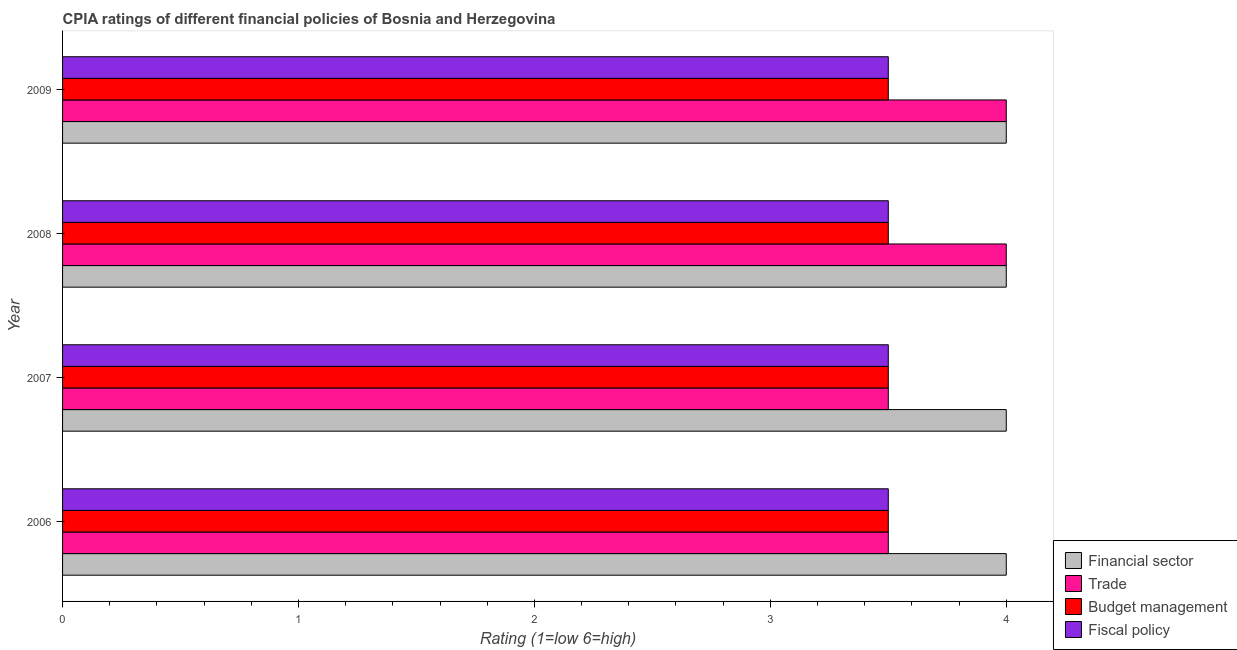How many groups of bars are there?
Your answer should be very brief. 4. How many bars are there on the 3rd tick from the bottom?
Provide a succinct answer. 4. What is the label of the 3rd group of bars from the top?
Your answer should be compact. 2007. What is the cpia rating of fiscal policy in 2007?
Ensure brevity in your answer.  3.5. Across all years, what is the maximum cpia rating of budget management?
Give a very brief answer. 3.5. Across all years, what is the minimum cpia rating of trade?
Provide a succinct answer. 3.5. In which year was the cpia rating of trade minimum?
Offer a very short reply. 2006. What is the difference between the cpia rating of financial sector in 2006 and that in 2009?
Your response must be concise. 0. What is the average cpia rating of financial sector per year?
Offer a very short reply. 4. What is the ratio of the cpia rating of financial sector in 2006 to that in 2008?
Give a very brief answer. 1. Is the cpia rating of budget management in 2006 less than that in 2007?
Offer a very short reply. No. What is the difference between the highest and the second highest cpia rating of trade?
Offer a terse response. 0. In how many years, is the cpia rating of trade greater than the average cpia rating of trade taken over all years?
Your response must be concise. 2. Is it the case that in every year, the sum of the cpia rating of budget management and cpia rating of trade is greater than the sum of cpia rating of fiscal policy and cpia rating of financial sector?
Your response must be concise. No. What does the 3rd bar from the top in 2007 represents?
Make the answer very short. Trade. What does the 1st bar from the bottom in 2007 represents?
Ensure brevity in your answer.  Financial sector. Are all the bars in the graph horizontal?
Make the answer very short. Yes. What is the difference between two consecutive major ticks on the X-axis?
Provide a short and direct response. 1. Does the graph contain any zero values?
Your answer should be very brief. No. Where does the legend appear in the graph?
Keep it short and to the point. Bottom right. How many legend labels are there?
Keep it short and to the point. 4. What is the title of the graph?
Your answer should be compact. CPIA ratings of different financial policies of Bosnia and Herzegovina. Does "WHO" appear as one of the legend labels in the graph?
Your answer should be compact. No. What is the label or title of the Y-axis?
Keep it short and to the point. Year. What is the Rating (1=low 6=high) of Financial sector in 2006?
Offer a terse response. 4. What is the Rating (1=low 6=high) in Trade in 2006?
Offer a very short reply. 3.5. What is the Rating (1=low 6=high) of Budget management in 2006?
Your answer should be very brief. 3.5. What is the Rating (1=low 6=high) in Fiscal policy in 2006?
Give a very brief answer. 3.5. What is the Rating (1=low 6=high) of Financial sector in 2007?
Make the answer very short. 4. What is the Rating (1=low 6=high) of Budget management in 2007?
Make the answer very short. 3.5. What is the Rating (1=low 6=high) in Fiscal policy in 2007?
Your answer should be compact. 3.5. What is the Rating (1=low 6=high) in Financial sector in 2008?
Provide a succinct answer. 4. What is the Rating (1=low 6=high) of Budget management in 2008?
Make the answer very short. 3.5. What is the Rating (1=low 6=high) of Fiscal policy in 2008?
Ensure brevity in your answer.  3.5. What is the Rating (1=low 6=high) of Financial sector in 2009?
Your response must be concise. 4. What is the Rating (1=low 6=high) in Budget management in 2009?
Make the answer very short. 3.5. Across all years, what is the maximum Rating (1=low 6=high) of Budget management?
Provide a succinct answer. 3.5. Across all years, what is the minimum Rating (1=low 6=high) in Trade?
Make the answer very short. 3.5. Across all years, what is the minimum Rating (1=low 6=high) of Budget management?
Your answer should be compact. 3.5. What is the total Rating (1=low 6=high) of Trade in the graph?
Provide a short and direct response. 15. What is the total Rating (1=low 6=high) in Budget management in the graph?
Your answer should be compact. 14. What is the total Rating (1=low 6=high) in Fiscal policy in the graph?
Offer a terse response. 14. What is the difference between the Rating (1=low 6=high) in Financial sector in 2006 and that in 2007?
Your response must be concise. 0. What is the difference between the Rating (1=low 6=high) in Trade in 2006 and that in 2007?
Your answer should be very brief. 0. What is the difference between the Rating (1=low 6=high) in Budget management in 2006 and that in 2007?
Provide a short and direct response. 0. What is the difference between the Rating (1=low 6=high) in Fiscal policy in 2006 and that in 2007?
Provide a succinct answer. 0. What is the difference between the Rating (1=low 6=high) in Financial sector in 2006 and that in 2008?
Provide a short and direct response. 0. What is the difference between the Rating (1=low 6=high) of Budget management in 2006 and that in 2008?
Provide a short and direct response. 0. What is the difference between the Rating (1=low 6=high) of Fiscal policy in 2006 and that in 2008?
Offer a very short reply. 0. What is the difference between the Rating (1=low 6=high) in Budget management in 2006 and that in 2009?
Give a very brief answer. 0. What is the difference between the Rating (1=low 6=high) in Trade in 2007 and that in 2008?
Offer a very short reply. -0.5. What is the difference between the Rating (1=low 6=high) in Fiscal policy in 2007 and that in 2008?
Provide a succinct answer. 0. What is the difference between the Rating (1=low 6=high) of Financial sector in 2007 and that in 2009?
Provide a succinct answer. 0. What is the difference between the Rating (1=low 6=high) of Trade in 2007 and that in 2009?
Ensure brevity in your answer.  -0.5. What is the difference between the Rating (1=low 6=high) in Budget management in 2007 and that in 2009?
Your answer should be very brief. 0. What is the difference between the Rating (1=low 6=high) in Financial sector in 2008 and that in 2009?
Make the answer very short. 0. What is the difference between the Rating (1=low 6=high) of Budget management in 2008 and that in 2009?
Provide a short and direct response. 0. What is the difference between the Rating (1=low 6=high) of Financial sector in 2006 and the Rating (1=low 6=high) of Trade in 2007?
Offer a terse response. 0.5. What is the difference between the Rating (1=low 6=high) in Financial sector in 2006 and the Rating (1=low 6=high) in Budget management in 2007?
Provide a succinct answer. 0.5. What is the difference between the Rating (1=low 6=high) of Financial sector in 2006 and the Rating (1=low 6=high) of Fiscal policy in 2007?
Offer a terse response. 0.5. What is the difference between the Rating (1=low 6=high) of Financial sector in 2006 and the Rating (1=low 6=high) of Budget management in 2008?
Make the answer very short. 0.5. What is the difference between the Rating (1=low 6=high) of Financial sector in 2006 and the Rating (1=low 6=high) of Fiscal policy in 2008?
Your answer should be compact. 0.5. What is the difference between the Rating (1=low 6=high) in Trade in 2006 and the Rating (1=low 6=high) in Budget management in 2008?
Keep it short and to the point. 0. What is the difference between the Rating (1=low 6=high) in Trade in 2006 and the Rating (1=low 6=high) in Fiscal policy in 2008?
Make the answer very short. 0. What is the difference between the Rating (1=low 6=high) in Budget management in 2006 and the Rating (1=low 6=high) in Fiscal policy in 2008?
Your response must be concise. 0. What is the difference between the Rating (1=low 6=high) of Financial sector in 2006 and the Rating (1=low 6=high) of Trade in 2009?
Your answer should be compact. 0. What is the difference between the Rating (1=low 6=high) of Financial sector in 2006 and the Rating (1=low 6=high) of Budget management in 2009?
Ensure brevity in your answer.  0.5. What is the difference between the Rating (1=low 6=high) of Financial sector in 2006 and the Rating (1=low 6=high) of Fiscal policy in 2009?
Keep it short and to the point. 0.5. What is the difference between the Rating (1=low 6=high) of Trade in 2006 and the Rating (1=low 6=high) of Budget management in 2009?
Your answer should be compact. 0. What is the difference between the Rating (1=low 6=high) in Budget management in 2006 and the Rating (1=low 6=high) in Fiscal policy in 2009?
Make the answer very short. 0. What is the difference between the Rating (1=low 6=high) of Trade in 2007 and the Rating (1=low 6=high) of Budget management in 2008?
Offer a very short reply. 0. What is the difference between the Rating (1=low 6=high) in Financial sector in 2007 and the Rating (1=low 6=high) in Budget management in 2009?
Your answer should be very brief. 0.5. What is the difference between the Rating (1=low 6=high) of Trade in 2007 and the Rating (1=low 6=high) of Budget management in 2009?
Give a very brief answer. 0. What is the difference between the Rating (1=low 6=high) of Trade in 2007 and the Rating (1=low 6=high) of Fiscal policy in 2009?
Ensure brevity in your answer.  0. What is the difference between the Rating (1=low 6=high) of Budget management in 2007 and the Rating (1=low 6=high) of Fiscal policy in 2009?
Offer a terse response. 0. What is the difference between the Rating (1=low 6=high) of Financial sector in 2008 and the Rating (1=low 6=high) of Budget management in 2009?
Ensure brevity in your answer.  0.5. What is the difference between the Rating (1=low 6=high) in Trade in 2008 and the Rating (1=low 6=high) in Budget management in 2009?
Provide a short and direct response. 0.5. What is the difference between the Rating (1=low 6=high) in Budget management in 2008 and the Rating (1=low 6=high) in Fiscal policy in 2009?
Your response must be concise. 0. What is the average Rating (1=low 6=high) of Trade per year?
Give a very brief answer. 3.75. What is the average Rating (1=low 6=high) of Budget management per year?
Provide a short and direct response. 3.5. In the year 2006, what is the difference between the Rating (1=low 6=high) of Trade and Rating (1=low 6=high) of Budget management?
Offer a terse response. 0. In the year 2006, what is the difference between the Rating (1=low 6=high) in Trade and Rating (1=low 6=high) in Fiscal policy?
Ensure brevity in your answer.  0. In the year 2007, what is the difference between the Rating (1=low 6=high) of Financial sector and Rating (1=low 6=high) of Trade?
Your answer should be compact. 0.5. In the year 2007, what is the difference between the Rating (1=low 6=high) in Financial sector and Rating (1=low 6=high) in Budget management?
Your answer should be very brief. 0.5. In the year 2007, what is the difference between the Rating (1=low 6=high) in Financial sector and Rating (1=low 6=high) in Fiscal policy?
Provide a succinct answer. 0.5. In the year 2007, what is the difference between the Rating (1=low 6=high) of Trade and Rating (1=low 6=high) of Budget management?
Offer a terse response. 0. In the year 2007, what is the difference between the Rating (1=low 6=high) of Budget management and Rating (1=low 6=high) of Fiscal policy?
Ensure brevity in your answer.  0. In the year 2008, what is the difference between the Rating (1=low 6=high) in Financial sector and Rating (1=low 6=high) in Trade?
Make the answer very short. 0. In the year 2008, what is the difference between the Rating (1=low 6=high) of Financial sector and Rating (1=low 6=high) of Budget management?
Your answer should be compact. 0.5. In the year 2008, what is the difference between the Rating (1=low 6=high) in Trade and Rating (1=low 6=high) in Budget management?
Offer a terse response. 0.5. In the year 2008, what is the difference between the Rating (1=low 6=high) of Trade and Rating (1=low 6=high) of Fiscal policy?
Offer a terse response. 0.5. In the year 2008, what is the difference between the Rating (1=low 6=high) of Budget management and Rating (1=low 6=high) of Fiscal policy?
Provide a short and direct response. 0. In the year 2009, what is the difference between the Rating (1=low 6=high) in Financial sector and Rating (1=low 6=high) in Trade?
Offer a very short reply. 0. In the year 2009, what is the difference between the Rating (1=low 6=high) of Financial sector and Rating (1=low 6=high) of Budget management?
Give a very brief answer. 0.5. In the year 2009, what is the difference between the Rating (1=low 6=high) of Trade and Rating (1=low 6=high) of Budget management?
Offer a very short reply. 0.5. In the year 2009, what is the difference between the Rating (1=low 6=high) in Trade and Rating (1=low 6=high) in Fiscal policy?
Provide a short and direct response. 0.5. What is the ratio of the Rating (1=low 6=high) in Budget management in 2006 to that in 2007?
Give a very brief answer. 1. What is the ratio of the Rating (1=low 6=high) in Financial sector in 2006 to that in 2008?
Offer a very short reply. 1. What is the ratio of the Rating (1=low 6=high) in Trade in 2006 to that in 2009?
Ensure brevity in your answer.  0.88. What is the ratio of the Rating (1=low 6=high) of Financial sector in 2007 to that in 2008?
Your response must be concise. 1. What is the ratio of the Rating (1=low 6=high) of Trade in 2007 to that in 2008?
Offer a terse response. 0.88. What is the ratio of the Rating (1=low 6=high) of Budget management in 2007 to that in 2008?
Provide a short and direct response. 1. What is the ratio of the Rating (1=low 6=high) in Financial sector in 2007 to that in 2009?
Provide a succinct answer. 1. What is the ratio of the Rating (1=low 6=high) in Budget management in 2007 to that in 2009?
Make the answer very short. 1. What is the ratio of the Rating (1=low 6=high) of Fiscal policy in 2007 to that in 2009?
Ensure brevity in your answer.  1. What is the ratio of the Rating (1=low 6=high) in Budget management in 2008 to that in 2009?
Keep it short and to the point. 1. What is the ratio of the Rating (1=low 6=high) in Fiscal policy in 2008 to that in 2009?
Provide a succinct answer. 1. What is the difference between the highest and the second highest Rating (1=low 6=high) of Budget management?
Keep it short and to the point. 0. What is the difference between the highest and the second highest Rating (1=low 6=high) in Fiscal policy?
Offer a terse response. 0. What is the difference between the highest and the lowest Rating (1=low 6=high) in Financial sector?
Ensure brevity in your answer.  0. What is the difference between the highest and the lowest Rating (1=low 6=high) of Fiscal policy?
Offer a terse response. 0. 